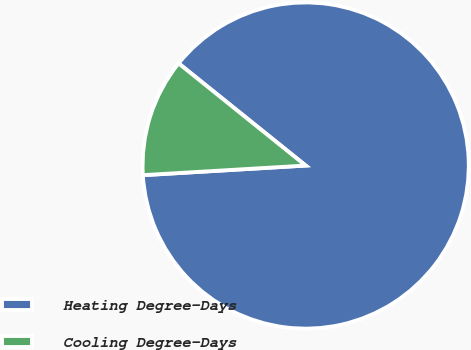<chart> <loc_0><loc_0><loc_500><loc_500><pie_chart><fcel>Heating Degree-Days<fcel>Cooling Degree-Days<nl><fcel>88.28%<fcel>11.72%<nl></chart> 